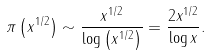Convert formula to latex. <formula><loc_0><loc_0><loc_500><loc_500>\pi \left ( x ^ { 1 / 2 } \right ) \sim \frac { x ^ { 1 / 2 } } { \log \left ( x ^ { 1 / 2 } \right ) } = \frac { 2 x ^ { 1 / 2 } } { \log { x } } .</formula> 